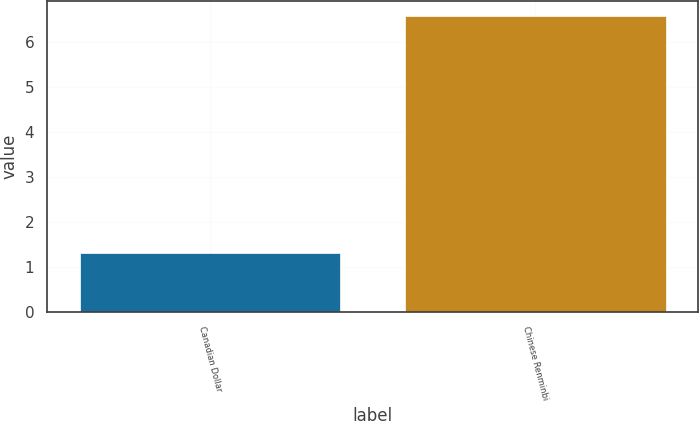Convert chart to OTSL. <chart><loc_0><loc_0><loc_500><loc_500><bar_chart><fcel>Canadian Dollar<fcel>Chinese Renminbi<nl><fcel>1.3<fcel>6.57<nl></chart> 